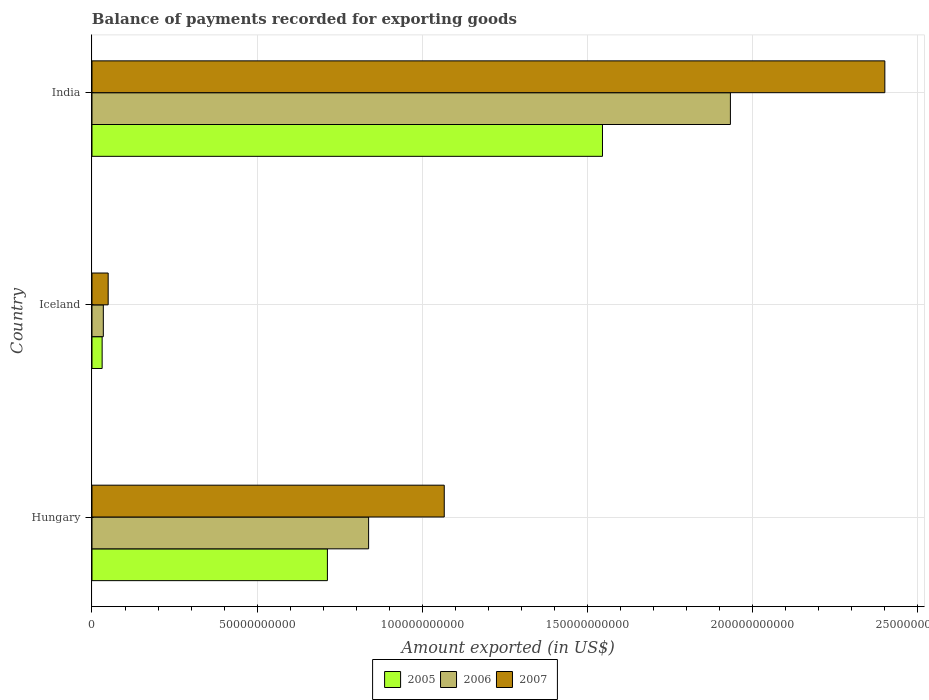How many groups of bars are there?
Provide a short and direct response. 3. Are the number of bars per tick equal to the number of legend labels?
Offer a very short reply. Yes. How many bars are there on the 3rd tick from the top?
Offer a terse response. 3. How many bars are there on the 1st tick from the bottom?
Your answer should be compact. 3. What is the label of the 3rd group of bars from the top?
Keep it short and to the point. Hungary. What is the amount exported in 2007 in India?
Provide a succinct answer. 2.40e+11. Across all countries, what is the maximum amount exported in 2005?
Your answer should be compact. 1.55e+11. Across all countries, what is the minimum amount exported in 2005?
Your response must be concise. 3.08e+09. In which country was the amount exported in 2007 maximum?
Keep it short and to the point. India. In which country was the amount exported in 2006 minimum?
Provide a short and direct response. Iceland. What is the total amount exported in 2005 in the graph?
Your response must be concise. 2.29e+11. What is the difference between the amount exported in 2005 in Iceland and that in India?
Offer a very short reply. -1.52e+11. What is the difference between the amount exported in 2005 in India and the amount exported in 2007 in Iceland?
Provide a short and direct response. 1.50e+11. What is the average amount exported in 2005 per country?
Your response must be concise. 7.63e+1. What is the difference between the amount exported in 2007 and amount exported in 2006 in India?
Your response must be concise. 4.68e+1. What is the ratio of the amount exported in 2005 in Hungary to that in Iceland?
Provide a succinct answer. 23.17. What is the difference between the highest and the second highest amount exported in 2006?
Make the answer very short. 1.10e+11. What is the difference between the highest and the lowest amount exported in 2006?
Your response must be concise. 1.90e+11. In how many countries, is the amount exported in 2006 greater than the average amount exported in 2006 taken over all countries?
Your answer should be very brief. 1. Is the sum of the amount exported in 2005 in Hungary and India greater than the maximum amount exported in 2006 across all countries?
Offer a very short reply. Yes. What does the 3rd bar from the top in India represents?
Provide a succinct answer. 2005. What does the 1st bar from the bottom in Hungary represents?
Give a very brief answer. 2005. How many bars are there?
Provide a short and direct response. 9. Are all the bars in the graph horizontal?
Provide a short and direct response. Yes. How many countries are there in the graph?
Keep it short and to the point. 3. Are the values on the major ticks of X-axis written in scientific E-notation?
Ensure brevity in your answer.  No. Where does the legend appear in the graph?
Make the answer very short. Bottom center. How many legend labels are there?
Provide a short and direct response. 3. How are the legend labels stacked?
Provide a short and direct response. Horizontal. What is the title of the graph?
Keep it short and to the point. Balance of payments recorded for exporting goods. What is the label or title of the X-axis?
Make the answer very short. Amount exported (in US$). What is the label or title of the Y-axis?
Your answer should be very brief. Country. What is the Amount exported (in US$) in 2005 in Hungary?
Your answer should be compact. 7.13e+1. What is the Amount exported (in US$) in 2006 in Hungary?
Offer a terse response. 8.38e+1. What is the Amount exported (in US$) of 2007 in Hungary?
Your answer should be very brief. 1.07e+11. What is the Amount exported (in US$) of 2005 in Iceland?
Your answer should be compact. 3.08e+09. What is the Amount exported (in US$) of 2006 in Iceland?
Keep it short and to the point. 3.44e+09. What is the Amount exported (in US$) in 2007 in Iceland?
Keep it short and to the point. 4.90e+09. What is the Amount exported (in US$) of 2005 in India?
Offer a very short reply. 1.55e+11. What is the Amount exported (in US$) in 2006 in India?
Offer a very short reply. 1.93e+11. What is the Amount exported (in US$) in 2007 in India?
Give a very brief answer. 2.40e+11. Across all countries, what is the maximum Amount exported (in US$) of 2005?
Your answer should be very brief. 1.55e+11. Across all countries, what is the maximum Amount exported (in US$) of 2006?
Ensure brevity in your answer.  1.93e+11. Across all countries, what is the maximum Amount exported (in US$) in 2007?
Your response must be concise. 2.40e+11. Across all countries, what is the minimum Amount exported (in US$) in 2005?
Offer a terse response. 3.08e+09. Across all countries, what is the minimum Amount exported (in US$) of 2006?
Make the answer very short. 3.44e+09. Across all countries, what is the minimum Amount exported (in US$) of 2007?
Your answer should be compact. 4.90e+09. What is the total Amount exported (in US$) of 2005 in the graph?
Your response must be concise. 2.29e+11. What is the total Amount exported (in US$) in 2006 in the graph?
Keep it short and to the point. 2.81e+11. What is the total Amount exported (in US$) in 2007 in the graph?
Ensure brevity in your answer.  3.52e+11. What is the difference between the Amount exported (in US$) in 2005 in Hungary and that in Iceland?
Ensure brevity in your answer.  6.82e+1. What is the difference between the Amount exported (in US$) in 2006 in Hungary and that in Iceland?
Your answer should be compact. 8.03e+1. What is the difference between the Amount exported (in US$) of 2007 in Hungary and that in Iceland?
Your answer should be compact. 1.02e+11. What is the difference between the Amount exported (in US$) in 2005 in Hungary and that in India?
Keep it short and to the point. -8.33e+1. What is the difference between the Amount exported (in US$) in 2006 in Hungary and that in India?
Offer a very short reply. -1.10e+11. What is the difference between the Amount exported (in US$) in 2007 in Hungary and that in India?
Keep it short and to the point. -1.33e+11. What is the difference between the Amount exported (in US$) of 2005 in Iceland and that in India?
Offer a terse response. -1.52e+11. What is the difference between the Amount exported (in US$) in 2006 in Iceland and that in India?
Keep it short and to the point. -1.90e+11. What is the difference between the Amount exported (in US$) in 2007 in Iceland and that in India?
Provide a succinct answer. -2.35e+11. What is the difference between the Amount exported (in US$) of 2005 in Hungary and the Amount exported (in US$) of 2006 in Iceland?
Ensure brevity in your answer.  6.79e+1. What is the difference between the Amount exported (in US$) of 2005 in Hungary and the Amount exported (in US$) of 2007 in Iceland?
Your answer should be compact. 6.64e+1. What is the difference between the Amount exported (in US$) in 2006 in Hungary and the Amount exported (in US$) in 2007 in Iceland?
Offer a very short reply. 7.89e+1. What is the difference between the Amount exported (in US$) of 2005 in Hungary and the Amount exported (in US$) of 2006 in India?
Provide a short and direct response. -1.22e+11. What is the difference between the Amount exported (in US$) of 2005 in Hungary and the Amount exported (in US$) of 2007 in India?
Your response must be concise. -1.69e+11. What is the difference between the Amount exported (in US$) in 2006 in Hungary and the Amount exported (in US$) in 2007 in India?
Offer a terse response. -1.56e+11. What is the difference between the Amount exported (in US$) of 2005 in Iceland and the Amount exported (in US$) of 2006 in India?
Your answer should be compact. -1.90e+11. What is the difference between the Amount exported (in US$) of 2005 in Iceland and the Amount exported (in US$) of 2007 in India?
Your answer should be very brief. -2.37e+11. What is the difference between the Amount exported (in US$) in 2006 in Iceland and the Amount exported (in US$) in 2007 in India?
Make the answer very short. -2.37e+11. What is the average Amount exported (in US$) in 2005 per country?
Your answer should be very brief. 7.63e+1. What is the average Amount exported (in US$) in 2006 per country?
Make the answer very short. 9.35e+1. What is the average Amount exported (in US$) of 2007 per country?
Your response must be concise. 1.17e+11. What is the difference between the Amount exported (in US$) of 2005 and Amount exported (in US$) of 2006 in Hungary?
Offer a very short reply. -1.25e+1. What is the difference between the Amount exported (in US$) of 2005 and Amount exported (in US$) of 2007 in Hungary?
Provide a short and direct response. -3.54e+1. What is the difference between the Amount exported (in US$) of 2006 and Amount exported (in US$) of 2007 in Hungary?
Provide a succinct answer. -2.29e+1. What is the difference between the Amount exported (in US$) in 2005 and Amount exported (in US$) in 2006 in Iceland?
Give a very brief answer. -3.61e+08. What is the difference between the Amount exported (in US$) in 2005 and Amount exported (in US$) in 2007 in Iceland?
Your response must be concise. -1.83e+09. What is the difference between the Amount exported (in US$) of 2006 and Amount exported (in US$) of 2007 in Iceland?
Make the answer very short. -1.47e+09. What is the difference between the Amount exported (in US$) in 2005 and Amount exported (in US$) in 2006 in India?
Provide a short and direct response. -3.87e+1. What is the difference between the Amount exported (in US$) in 2005 and Amount exported (in US$) in 2007 in India?
Offer a terse response. -8.55e+1. What is the difference between the Amount exported (in US$) of 2006 and Amount exported (in US$) of 2007 in India?
Keep it short and to the point. -4.68e+1. What is the ratio of the Amount exported (in US$) in 2005 in Hungary to that in Iceland?
Give a very brief answer. 23.17. What is the ratio of the Amount exported (in US$) in 2006 in Hungary to that in Iceland?
Give a very brief answer. 24.37. What is the ratio of the Amount exported (in US$) of 2007 in Hungary to that in Iceland?
Ensure brevity in your answer.  21.75. What is the ratio of the Amount exported (in US$) in 2005 in Hungary to that in India?
Offer a terse response. 0.46. What is the ratio of the Amount exported (in US$) of 2006 in Hungary to that in India?
Your answer should be very brief. 0.43. What is the ratio of the Amount exported (in US$) in 2007 in Hungary to that in India?
Make the answer very short. 0.44. What is the ratio of the Amount exported (in US$) of 2005 in Iceland to that in India?
Give a very brief answer. 0.02. What is the ratio of the Amount exported (in US$) of 2006 in Iceland to that in India?
Give a very brief answer. 0.02. What is the ratio of the Amount exported (in US$) of 2007 in Iceland to that in India?
Your response must be concise. 0.02. What is the difference between the highest and the second highest Amount exported (in US$) of 2005?
Give a very brief answer. 8.33e+1. What is the difference between the highest and the second highest Amount exported (in US$) in 2006?
Make the answer very short. 1.10e+11. What is the difference between the highest and the second highest Amount exported (in US$) in 2007?
Offer a very short reply. 1.33e+11. What is the difference between the highest and the lowest Amount exported (in US$) of 2005?
Provide a short and direct response. 1.52e+11. What is the difference between the highest and the lowest Amount exported (in US$) in 2006?
Your response must be concise. 1.90e+11. What is the difference between the highest and the lowest Amount exported (in US$) of 2007?
Offer a very short reply. 2.35e+11. 